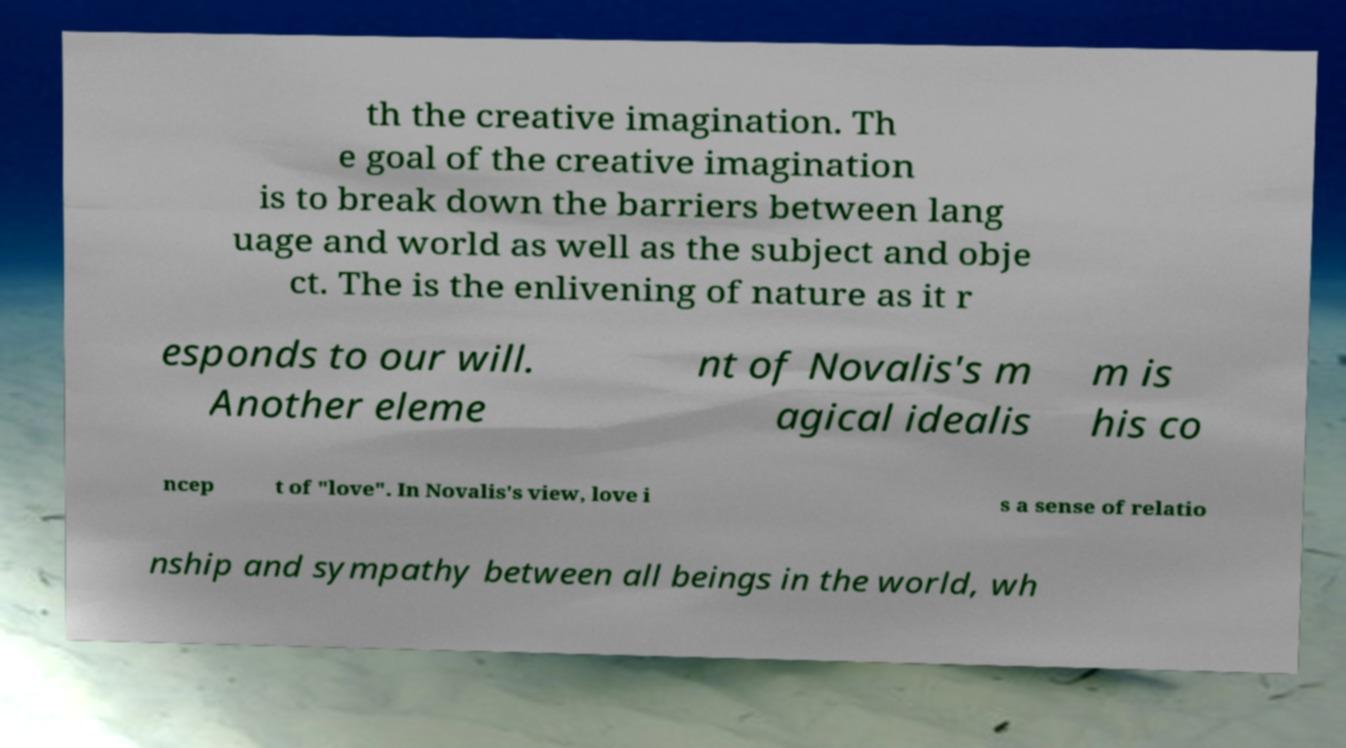For documentation purposes, I need the text within this image transcribed. Could you provide that? th the creative imagination. Th e goal of the creative imagination is to break down the barriers between lang uage and world as well as the subject and obje ct. The is the enlivening of nature as it r esponds to our will. Another eleme nt of Novalis's m agical idealis m is his co ncep t of "love". In Novalis's view, love i s a sense of relatio nship and sympathy between all beings in the world, wh 